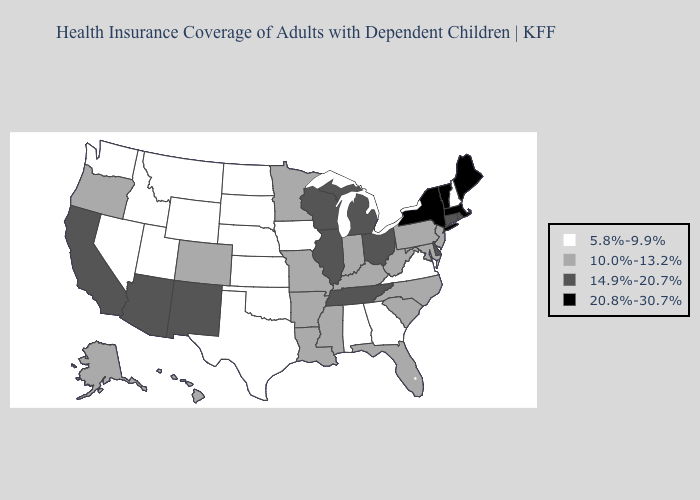What is the value of Iowa?
Keep it brief. 5.8%-9.9%. Which states have the lowest value in the USA?
Be succinct. Alabama, Georgia, Idaho, Iowa, Kansas, Montana, Nebraska, Nevada, New Hampshire, North Dakota, Oklahoma, South Dakota, Texas, Utah, Virginia, Washington, Wyoming. Does West Virginia have the highest value in the USA?
Answer briefly. No. Does Nebraska have the same value as Pennsylvania?
Concise answer only. No. Which states hav the highest value in the West?
Answer briefly. Arizona, California, New Mexico. Name the states that have a value in the range 5.8%-9.9%?
Quick response, please. Alabama, Georgia, Idaho, Iowa, Kansas, Montana, Nebraska, Nevada, New Hampshire, North Dakota, Oklahoma, South Dakota, Texas, Utah, Virginia, Washington, Wyoming. Which states have the highest value in the USA?
Be succinct. Maine, Massachusetts, New York, Vermont. Does the first symbol in the legend represent the smallest category?
Concise answer only. Yes. What is the highest value in states that border West Virginia?
Quick response, please. 14.9%-20.7%. Name the states that have a value in the range 5.8%-9.9%?
Answer briefly. Alabama, Georgia, Idaho, Iowa, Kansas, Montana, Nebraska, Nevada, New Hampshire, North Dakota, Oklahoma, South Dakota, Texas, Utah, Virginia, Washington, Wyoming. Name the states that have a value in the range 20.8%-30.7%?
Write a very short answer. Maine, Massachusetts, New York, Vermont. What is the value of Wisconsin?
Short answer required. 14.9%-20.7%. What is the highest value in the Northeast ?
Quick response, please. 20.8%-30.7%. What is the highest value in the USA?
Keep it brief. 20.8%-30.7%. What is the value of North Carolina?
Keep it brief. 10.0%-13.2%. 